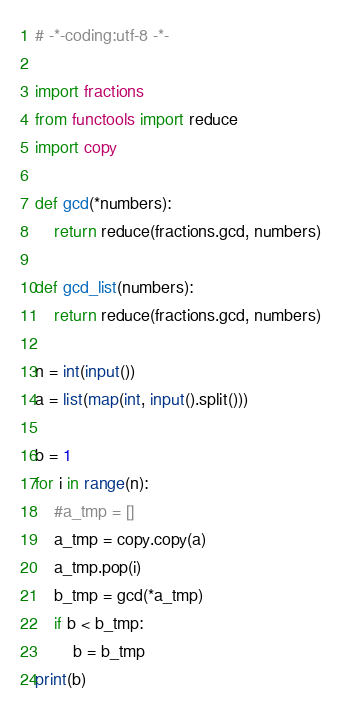<code> <loc_0><loc_0><loc_500><loc_500><_Python_># -*-coding:utf-8 -*-

import fractions
from functools import reduce
import copy

def gcd(*numbers):
    return reduce(fractions.gcd, numbers)

def gcd_list(numbers):
    return reduce(fractions.gcd, numbers)

n = int(input())
a = list(map(int, input().split()))

b = 1
for i in range(n):
    #a_tmp = []
    a_tmp = copy.copy(a)
    a_tmp.pop(i)
    b_tmp = gcd(*a_tmp)
    if b < b_tmp:
        b = b_tmp
print(b)

</code> 